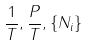<formula> <loc_0><loc_0><loc_500><loc_500>\frac { 1 } { T } , \frac { P } { T } , \{ N _ { i } \}</formula> 